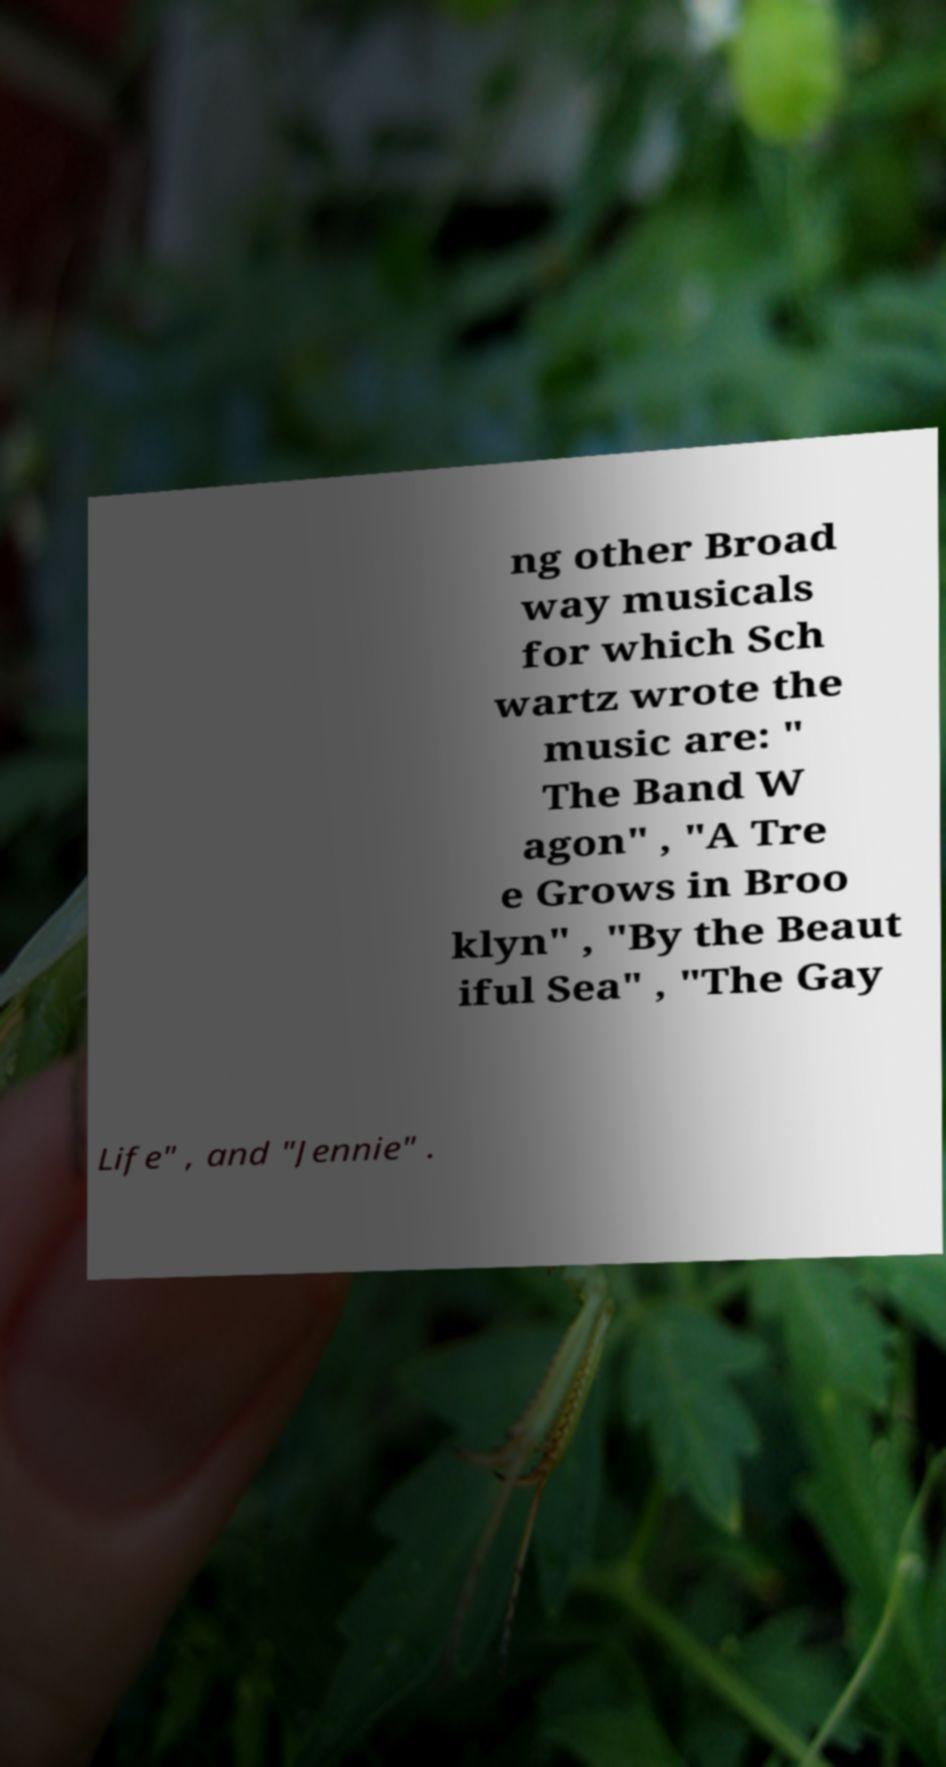Could you extract and type out the text from this image? ng other Broad way musicals for which Sch wartz wrote the music are: " The Band W agon" , "A Tre e Grows in Broo klyn" , "By the Beaut iful Sea" , "The Gay Life" , and "Jennie" . 